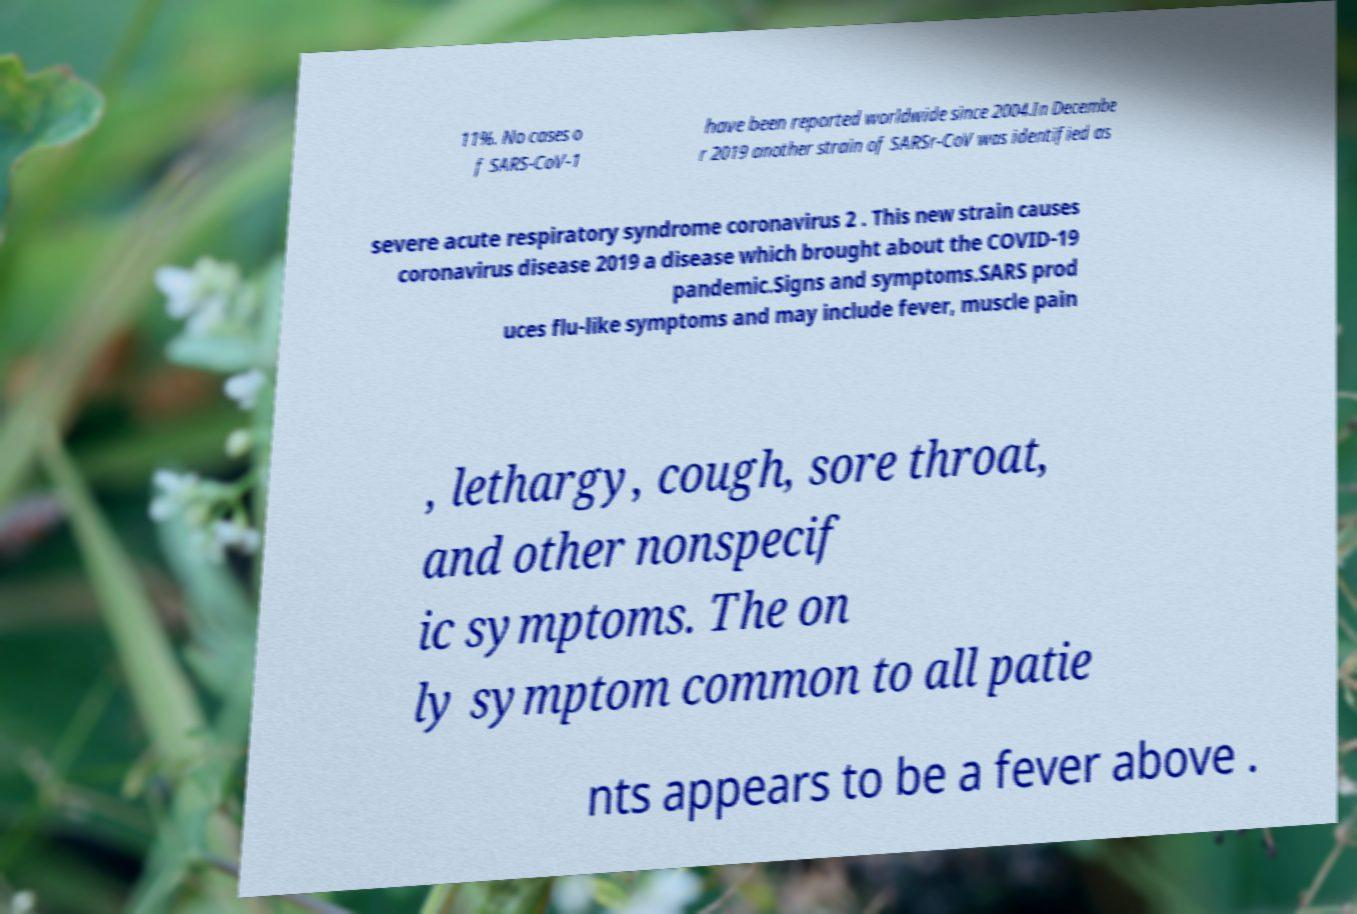Please read and relay the text visible in this image. What does it say? 11%. No cases o f SARS-CoV-1 have been reported worldwide since 2004.In Decembe r 2019 another strain of SARSr-CoV was identified as severe acute respiratory syndrome coronavirus 2 . This new strain causes coronavirus disease 2019 a disease which brought about the COVID-19 pandemic.Signs and symptoms.SARS prod uces flu-like symptoms and may include fever, muscle pain , lethargy, cough, sore throat, and other nonspecif ic symptoms. The on ly symptom common to all patie nts appears to be a fever above . 